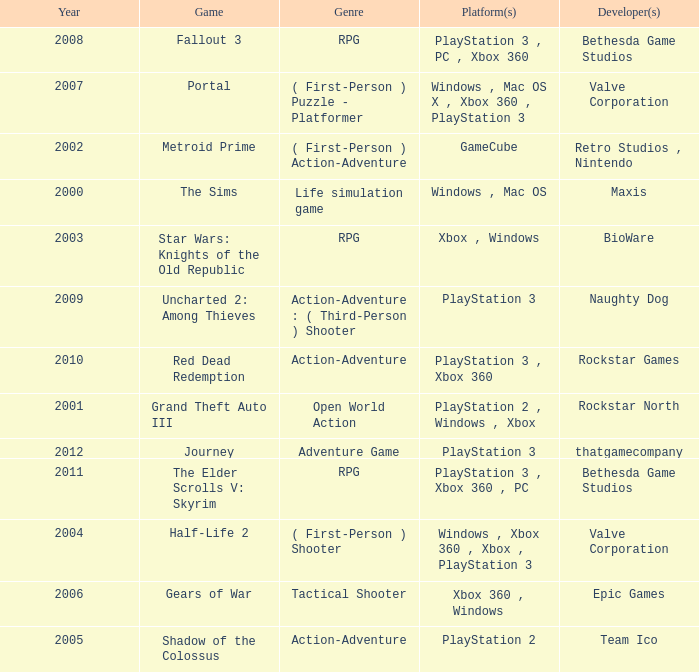What's the platform that has Rockstar Games as the developer? PlayStation 3 , Xbox 360. 